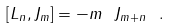Convert formula to latex. <formula><loc_0><loc_0><loc_500><loc_500>[ L _ { n } , J _ { m } ] = - m \ J _ { m + n } \ .</formula> 